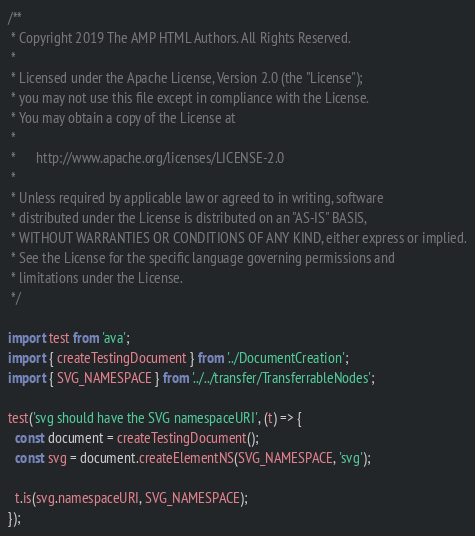<code> <loc_0><loc_0><loc_500><loc_500><_TypeScript_>/**
 * Copyright 2019 The AMP HTML Authors. All Rights Reserved.
 *
 * Licensed under the Apache License, Version 2.0 (the "License");
 * you may not use this file except in compliance with the License.
 * You may obtain a copy of the License at
 *
 *      http://www.apache.org/licenses/LICENSE-2.0
 *
 * Unless required by applicable law or agreed to in writing, software
 * distributed under the License is distributed on an "AS-IS" BASIS,
 * WITHOUT WARRANTIES OR CONDITIONS OF ANY KIND, either express or implied.
 * See the License for the specific language governing permissions and
 * limitations under the License.
 */

import test from 'ava';
import { createTestingDocument } from '../DocumentCreation';
import { SVG_NAMESPACE } from '../../transfer/TransferrableNodes';

test('svg should have the SVG namespaceURI', (t) => {
  const document = createTestingDocument();
  const svg = document.createElementNS(SVG_NAMESPACE, 'svg');

  t.is(svg.namespaceURI, SVG_NAMESPACE);
});
</code> 